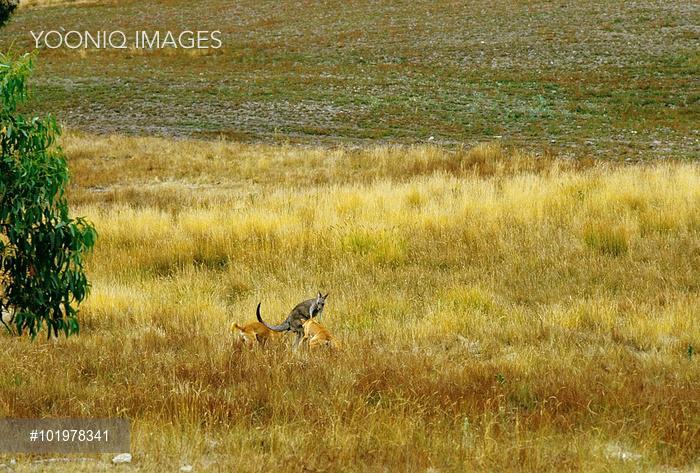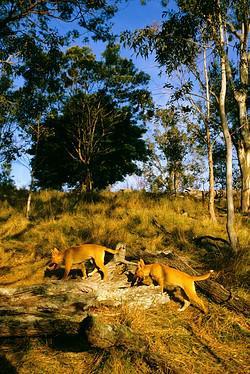The first image is the image on the left, the second image is the image on the right. For the images displayed, is the sentence "An upright kangaroo is flanked by two attacking dingos in the image on the left." factually correct? Answer yes or no. Yes. The first image is the image on the left, the second image is the image on the right. Assess this claim about the two images: "A kangaroo is being attacked by two coyotes.". Correct or not? Answer yes or no. Yes. 